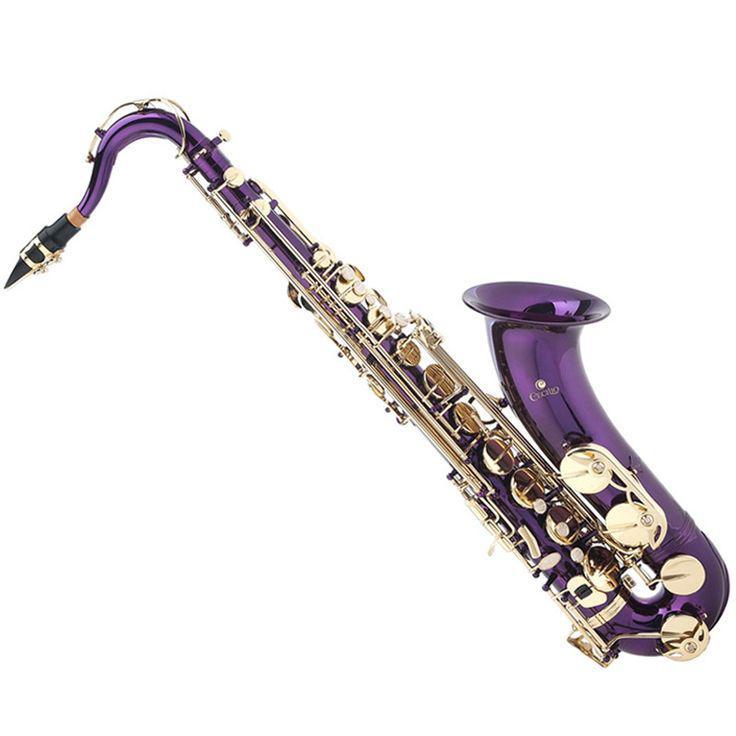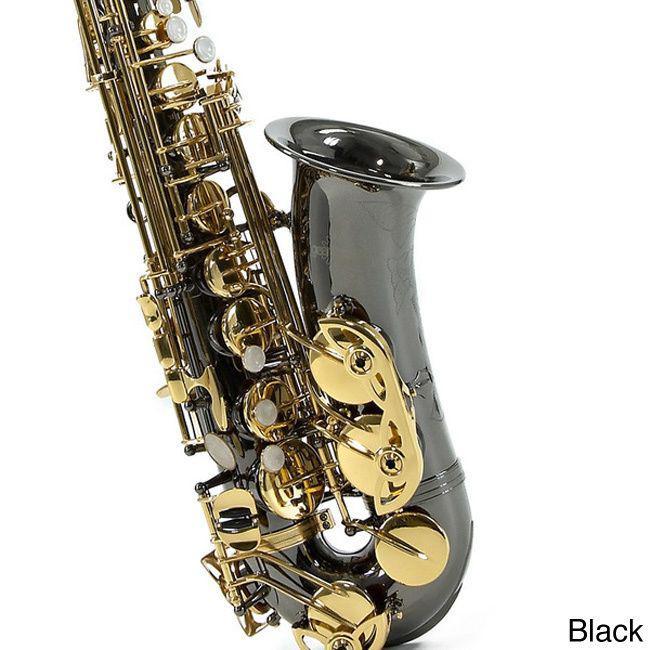The first image is the image on the left, the second image is the image on the right. For the images displayed, is the sentence "At least one saxophone is not a traditional metal color." factually correct? Answer yes or no. Yes. The first image is the image on the left, the second image is the image on the right. For the images shown, is this caption "Both of the saxophones are set up in the same position." true? Answer yes or no. No. 